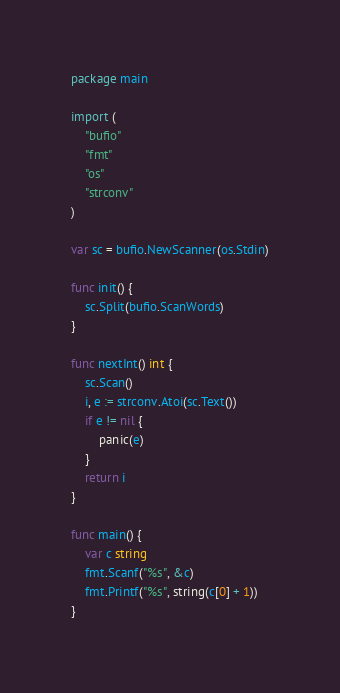<code> <loc_0><loc_0><loc_500><loc_500><_Go_>package main

import (
	"bufio"
	"fmt"
	"os"
	"strconv"
)

var sc = bufio.NewScanner(os.Stdin)

func init() {
	sc.Split(bufio.ScanWords)
}

func nextInt() int {
	sc.Scan()
	i, e := strconv.Atoi(sc.Text())
	if e != nil {
		panic(e)
	}
	return i
}

func main() {
	var c string
	fmt.Scanf("%s", &c)
	fmt.Printf("%s", string(c[0] + 1))
}
</code> 